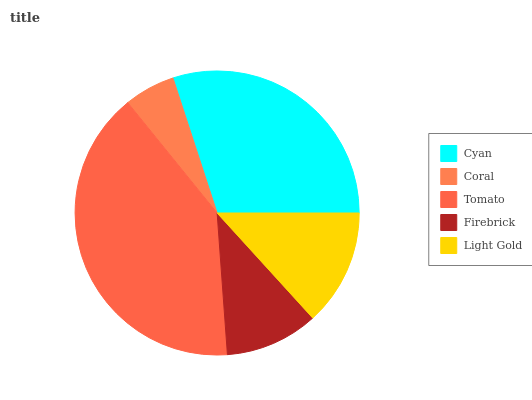Is Coral the minimum?
Answer yes or no. Yes. Is Tomato the maximum?
Answer yes or no. Yes. Is Tomato the minimum?
Answer yes or no. No. Is Coral the maximum?
Answer yes or no. No. Is Tomato greater than Coral?
Answer yes or no. Yes. Is Coral less than Tomato?
Answer yes or no. Yes. Is Coral greater than Tomato?
Answer yes or no. No. Is Tomato less than Coral?
Answer yes or no. No. Is Light Gold the high median?
Answer yes or no. Yes. Is Light Gold the low median?
Answer yes or no. Yes. Is Tomato the high median?
Answer yes or no. No. Is Coral the low median?
Answer yes or no. No. 